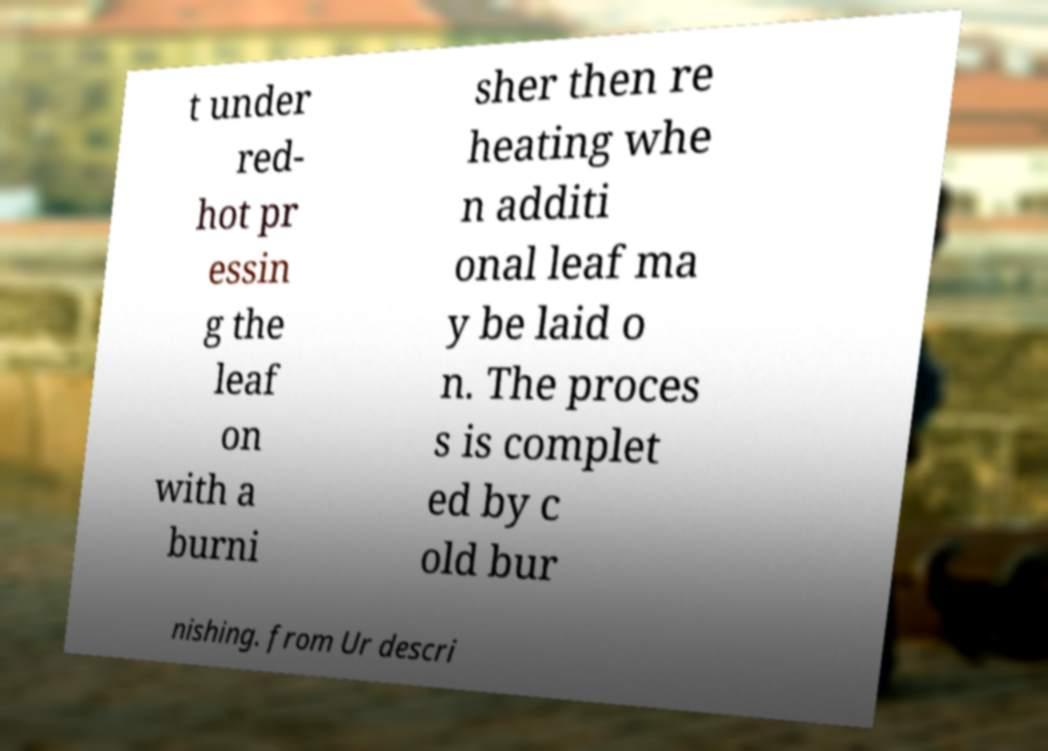Can you accurately transcribe the text from the provided image for me? t under red- hot pr essin g the leaf on with a burni sher then re heating whe n additi onal leaf ma y be laid o n. The proces s is complet ed by c old bur nishing. from Ur descri 